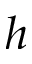Convert formula to latex. <formula><loc_0><loc_0><loc_500><loc_500>h</formula> 